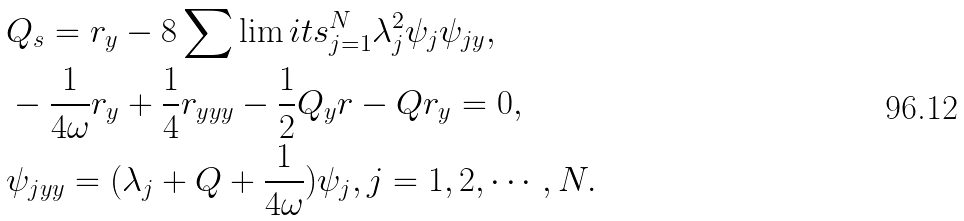Convert formula to latex. <formula><loc_0><loc_0><loc_500><loc_500>& Q _ { s } = r _ { y } - 8 \sum \lim i t s _ { j = 1 } ^ { N } \lambda _ { j } ^ { 2 } \psi _ { j } \psi _ { j y } , \\ & - \frac { 1 } { 4 \omega } r _ { y } + \frac { 1 } { 4 } r _ { y y y } - \frac { 1 } { 2 } Q _ { y } r - Q r _ { y } = 0 , \\ & \psi _ { j y y } = ( \lambda _ { j } + Q + \frac { 1 } { 4 \omega } ) \psi _ { j } , j = 1 , 2 , \cdots , N .</formula> 